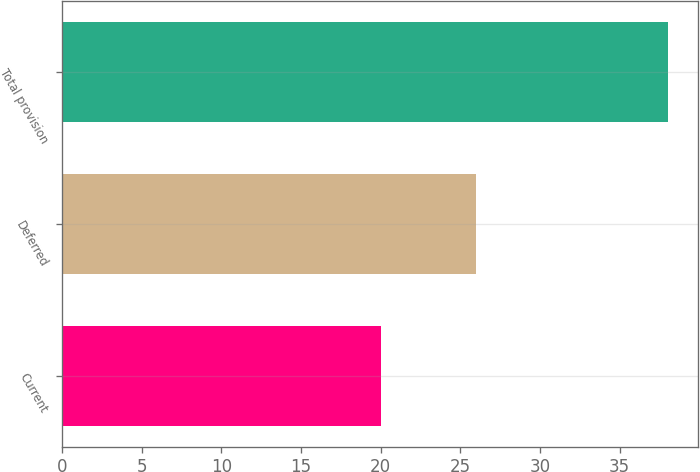<chart> <loc_0><loc_0><loc_500><loc_500><bar_chart><fcel>Current<fcel>Deferred<fcel>Total provision<nl><fcel>20<fcel>26<fcel>38<nl></chart> 